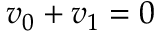<formula> <loc_0><loc_0><loc_500><loc_500>v _ { 0 } + v _ { 1 } = 0</formula> 